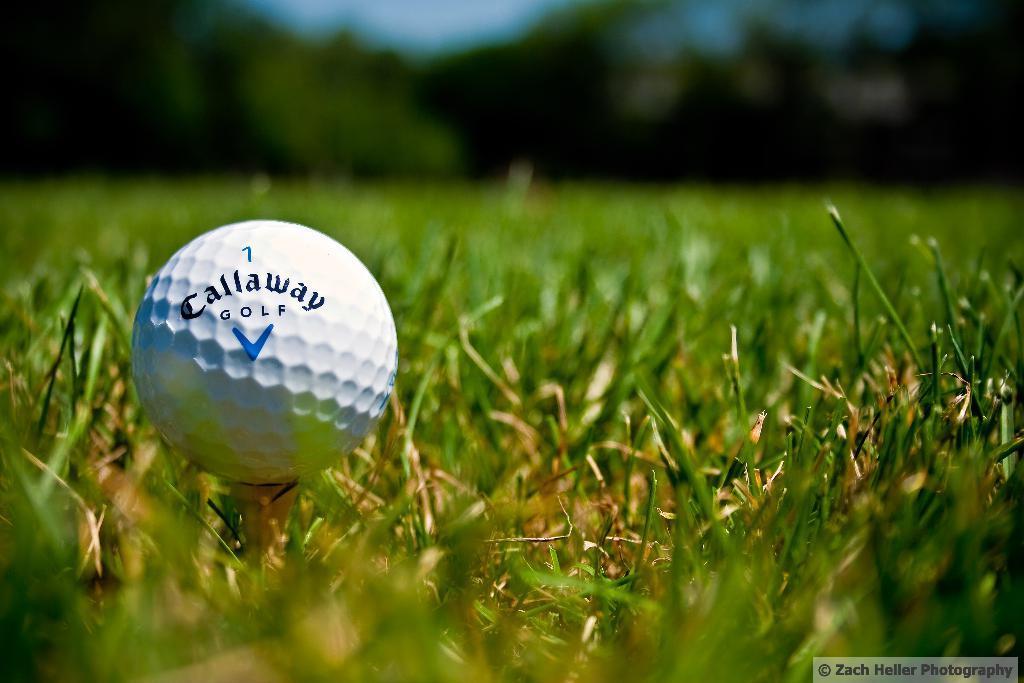In one or two sentences, can you explain what this image depicts? In this image there is a golf ball on the surface of the grass, in the background of the image there are trees. 